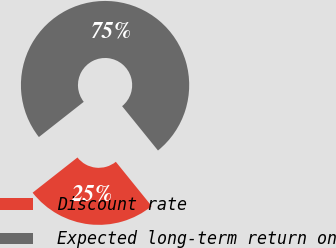Convert chart to OTSL. <chart><loc_0><loc_0><loc_500><loc_500><pie_chart><fcel>Discount rate<fcel>Expected long-term return on<nl><fcel>25.23%<fcel>74.77%<nl></chart> 